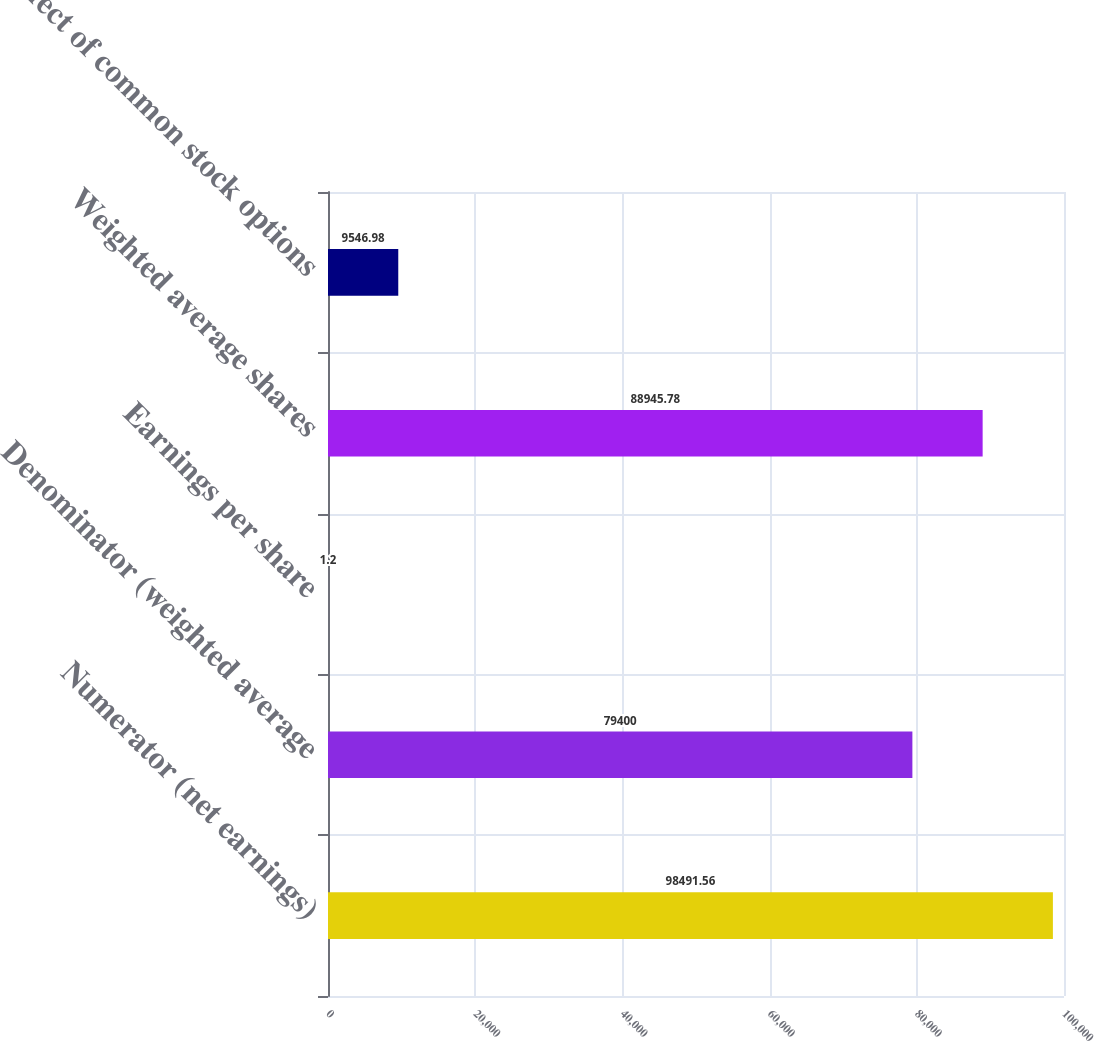Convert chart. <chart><loc_0><loc_0><loc_500><loc_500><bar_chart><fcel>Numerator (net earnings)<fcel>Denominator (weighted average<fcel>Earnings per share<fcel>Weighted average shares<fcel>Effect of common stock options<nl><fcel>98491.6<fcel>79400<fcel>1.2<fcel>88945.8<fcel>9546.98<nl></chart> 